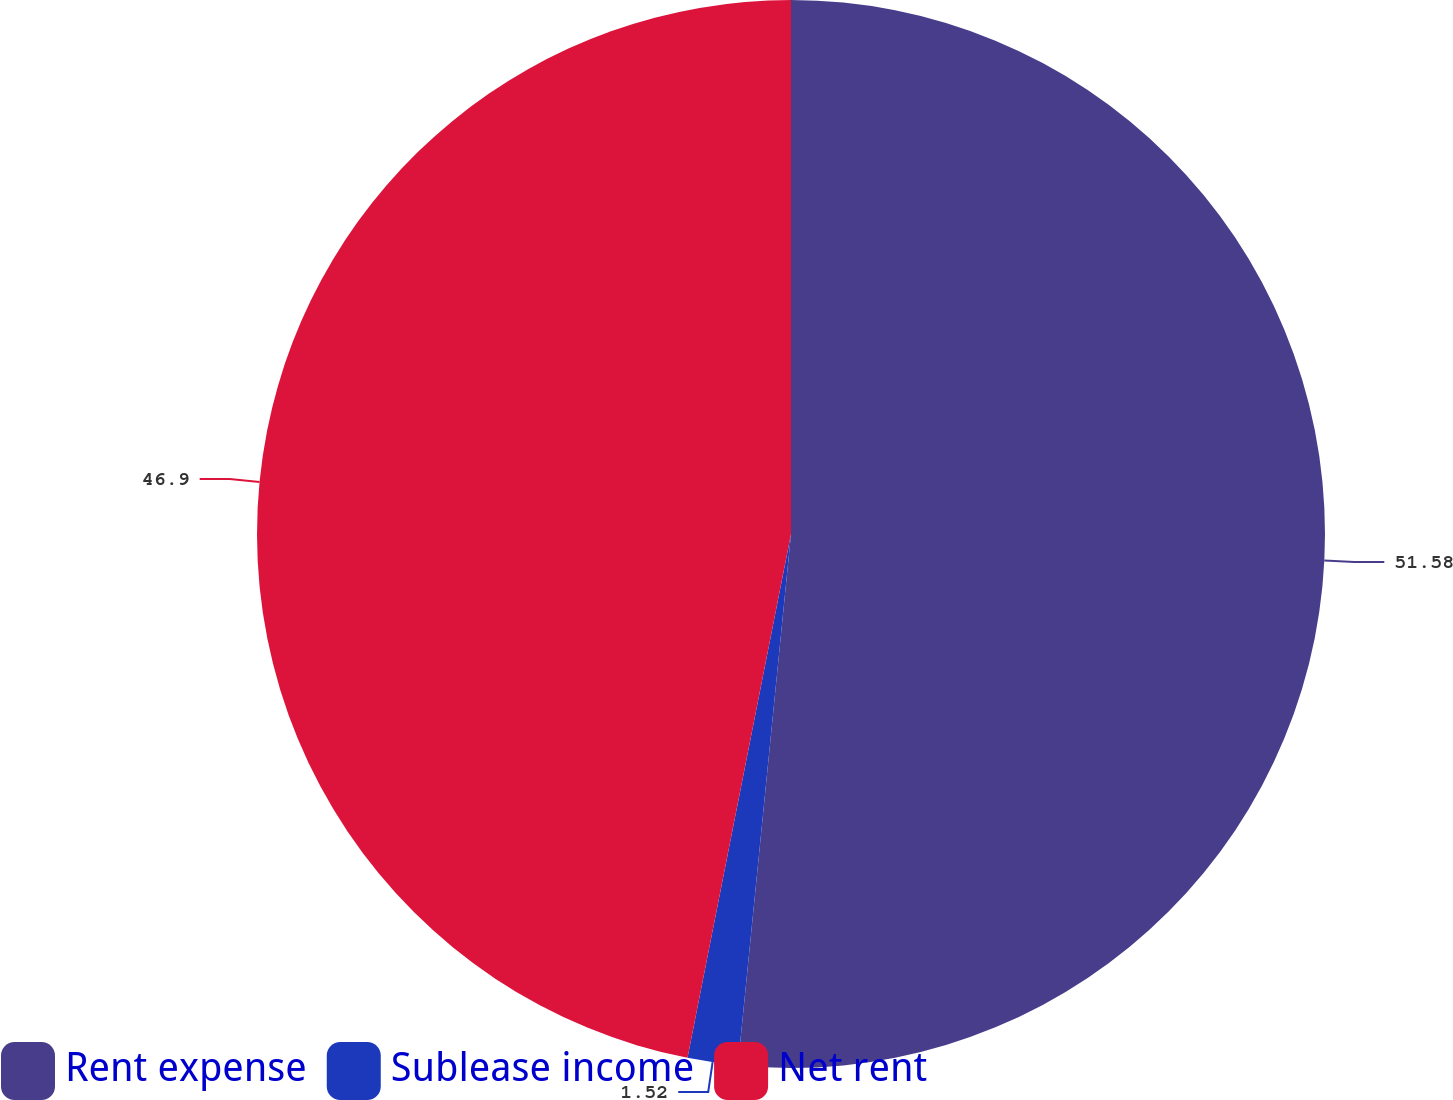<chart> <loc_0><loc_0><loc_500><loc_500><pie_chart><fcel>Rent expense<fcel>Sublease income<fcel>Net rent<nl><fcel>51.59%<fcel>1.52%<fcel>46.9%<nl></chart> 